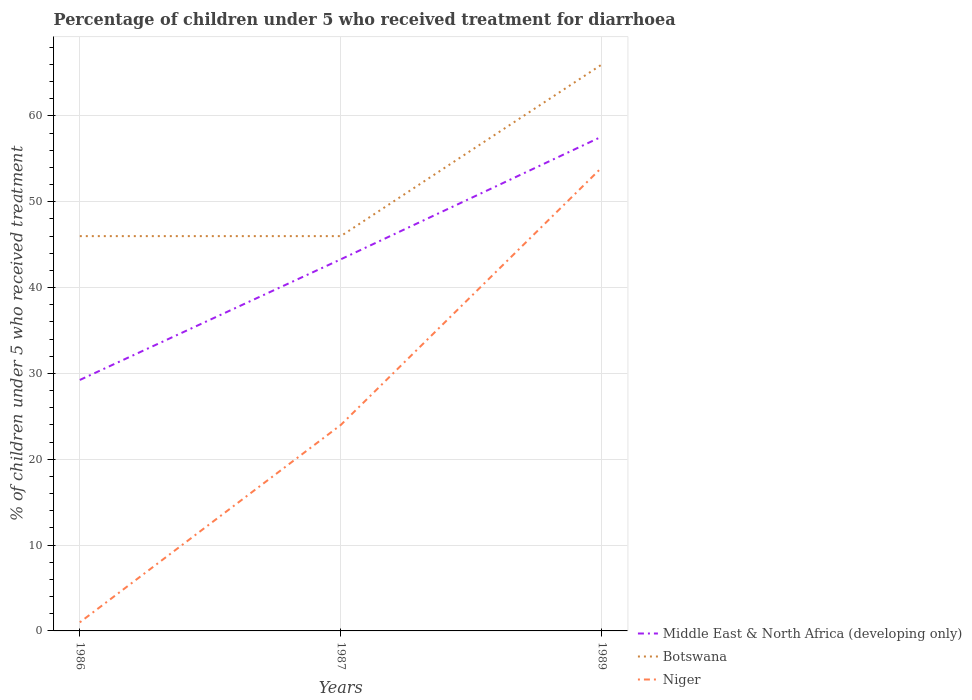How many different coloured lines are there?
Offer a terse response. 3. Does the line corresponding to Niger intersect with the line corresponding to Botswana?
Ensure brevity in your answer.  No. Across all years, what is the maximum percentage of children who received treatment for diarrhoea  in Middle East & North Africa (developing only)?
Your answer should be compact. 29.24. What is the total percentage of children who received treatment for diarrhoea  in Niger in the graph?
Offer a very short reply. -23. Is the percentage of children who received treatment for diarrhoea  in Niger strictly greater than the percentage of children who received treatment for diarrhoea  in Middle East & North Africa (developing only) over the years?
Provide a short and direct response. Yes. How many lines are there?
Keep it short and to the point. 3. How many years are there in the graph?
Keep it short and to the point. 3. Are the values on the major ticks of Y-axis written in scientific E-notation?
Your response must be concise. No. Does the graph contain any zero values?
Keep it short and to the point. No. Where does the legend appear in the graph?
Offer a very short reply. Bottom right. How are the legend labels stacked?
Make the answer very short. Vertical. What is the title of the graph?
Give a very brief answer. Percentage of children under 5 who received treatment for diarrhoea. Does "Costa Rica" appear as one of the legend labels in the graph?
Provide a short and direct response. No. What is the label or title of the Y-axis?
Your answer should be compact. % of children under 5 who received treatment. What is the % of children under 5 who received treatment in Middle East & North Africa (developing only) in 1986?
Your response must be concise. 29.24. What is the % of children under 5 who received treatment of Botswana in 1986?
Ensure brevity in your answer.  46. What is the % of children under 5 who received treatment in Middle East & North Africa (developing only) in 1987?
Ensure brevity in your answer.  43.3. What is the % of children under 5 who received treatment in Niger in 1987?
Give a very brief answer. 24. What is the % of children under 5 who received treatment of Middle East & North Africa (developing only) in 1989?
Offer a terse response. 57.6. Across all years, what is the maximum % of children under 5 who received treatment of Middle East & North Africa (developing only)?
Offer a very short reply. 57.6. Across all years, what is the maximum % of children under 5 who received treatment of Botswana?
Provide a short and direct response. 66. Across all years, what is the minimum % of children under 5 who received treatment of Middle East & North Africa (developing only)?
Keep it short and to the point. 29.24. Across all years, what is the minimum % of children under 5 who received treatment of Niger?
Provide a short and direct response. 1. What is the total % of children under 5 who received treatment of Middle East & North Africa (developing only) in the graph?
Offer a terse response. 130.14. What is the total % of children under 5 who received treatment of Botswana in the graph?
Your response must be concise. 158. What is the total % of children under 5 who received treatment of Niger in the graph?
Make the answer very short. 79. What is the difference between the % of children under 5 who received treatment in Middle East & North Africa (developing only) in 1986 and that in 1987?
Provide a succinct answer. -14.06. What is the difference between the % of children under 5 who received treatment in Middle East & North Africa (developing only) in 1986 and that in 1989?
Provide a short and direct response. -28.36. What is the difference between the % of children under 5 who received treatment of Niger in 1986 and that in 1989?
Keep it short and to the point. -53. What is the difference between the % of children under 5 who received treatment in Middle East & North Africa (developing only) in 1987 and that in 1989?
Offer a very short reply. -14.3. What is the difference between the % of children under 5 who received treatment of Niger in 1987 and that in 1989?
Your answer should be very brief. -30. What is the difference between the % of children under 5 who received treatment in Middle East & North Africa (developing only) in 1986 and the % of children under 5 who received treatment in Botswana in 1987?
Make the answer very short. -16.76. What is the difference between the % of children under 5 who received treatment in Middle East & North Africa (developing only) in 1986 and the % of children under 5 who received treatment in Niger in 1987?
Offer a terse response. 5.24. What is the difference between the % of children under 5 who received treatment in Middle East & North Africa (developing only) in 1986 and the % of children under 5 who received treatment in Botswana in 1989?
Offer a terse response. -36.76. What is the difference between the % of children under 5 who received treatment in Middle East & North Africa (developing only) in 1986 and the % of children under 5 who received treatment in Niger in 1989?
Your response must be concise. -24.76. What is the difference between the % of children under 5 who received treatment of Botswana in 1986 and the % of children under 5 who received treatment of Niger in 1989?
Make the answer very short. -8. What is the difference between the % of children under 5 who received treatment in Middle East & North Africa (developing only) in 1987 and the % of children under 5 who received treatment in Botswana in 1989?
Keep it short and to the point. -22.7. What is the difference between the % of children under 5 who received treatment in Middle East & North Africa (developing only) in 1987 and the % of children under 5 who received treatment in Niger in 1989?
Provide a short and direct response. -10.7. What is the difference between the % of children under 5 who received treatment in Botswana in 1987 and the % of children under 5 who received treatment in Niger in 1989?
Your response must be concise. -8. What is the average % of children under 5 who received treatment of Middle East & North Africa (developing only) per year?
Offer a terse response. 43.38. What is the average % of children under 5 who received treatment of Botswana per year?
Make the answer very short. 52.67. What is the average % of children under 5 who received treatment of Niger per year?
Your answer should be very brief. 26.33. In the year 1986, what is the difference between the % of children under 5 who received treatment of Middle East & North Africa (developing only) and % of children under 5 who received treatment of Botswana?
Offer a terse response. -16.76. In the year 1986, what is the difference between the % of children under 5 who received treatment of Middle East & North Africa (developing only) and % of children under 5 who received treatment of Niger?
Offer a very short reply. 28.24. In the year 1986, what is the difference between the % of children under 5 who received treatment in Botswana and % of children under 5 who received treatment in Niger?
Make the answer very short. 45. In the year 1987, what is the difference between the % of children under 5 who received treatment in Middle East & North Africa (developing only) and % of children under 5 who received treatment in Botswana?
Give a very brief answer. -2.7. In the year 1987, what is the difference between the % of children under 5 who received treatment of Middle East & North Africa (developing only) and % of children under 5 who received treatment of Niger?
Make the answer very short. 19.3. In the year 1987, what is the difference between the % of children under 5 who received treatment of Botswana and % of children under 5 who received treatment of Niger?
Provide a short and direct response. 22. In the year 1989, what is the difference between the % of children under 5 who received treatment of Middle East & North Africa (developing only) and % of children under 5 who received treatment of Botswana?
Ensure brevity in your answer.  -8.4. In the year 1989, what is the difference between the % of children under 5 who received treatment in Middle East & North Africa (developing only) and % of children under 5 who received treatment in Niger?
Your answer should be compact. 3.6. What is the ratio of the % of children under 5 who received treatment in Middle East & North Africa (developing only) in 1986 to that in 1987?
Provide a succinct answer. 0.68. What is the ratio of the % of children under 5 who received treatment in Niger in 1986 to that in 1987?
Your answer should be very brief. 0.04. What is the ratio of the % of children under 5 who received treatment in Middle East & North Africa (developing only) in 1986 to that in 1989?
Give a very brief answer. 0.51. What is the ratio of the % of children under 5 who received treatment in Botswana in 1986 to that in 1989?
Offer a terse response. 0.7. What is the ratio of the % of children under 5 who received treatment in Niger in 1986 to that in 1989?
Provide a succinct answer. 0.02. What is the ratio of the % of children under 5 who received treatment in Middle East & North Africa (developing only) in 1987 to that in 1989?
Offer a very short reply. 0.75. What is the ratio of the % of children under 5 who received treatment of Botswana in 1987 to that in 1989?
Ensure brevity in your answer.  0.7. What is the ratio of the % of children under 5 who received treatment of Niger in 1987 to that in 1989?
Make the answer very short. 0.44. What is the difference between the highest and the second highest % of children under 5 who received treatment of Middle East & North Africa (developing only)?
Provide a short and direct response. 14.3. What is the difference between the highest and the second highest % of children under 5 who received treatment in Niger?
Provide a succinct answer. 30. What is the difference between the highest and the lowest % of children under 5 who received treatment of Middle East & North Africa (developing only)?
Ensure brevity in your answer.  28.36. What is the difference between the highest and the lowest % of children under 5 who received treatment in Niger?
Provide a succinct answer. 53. 